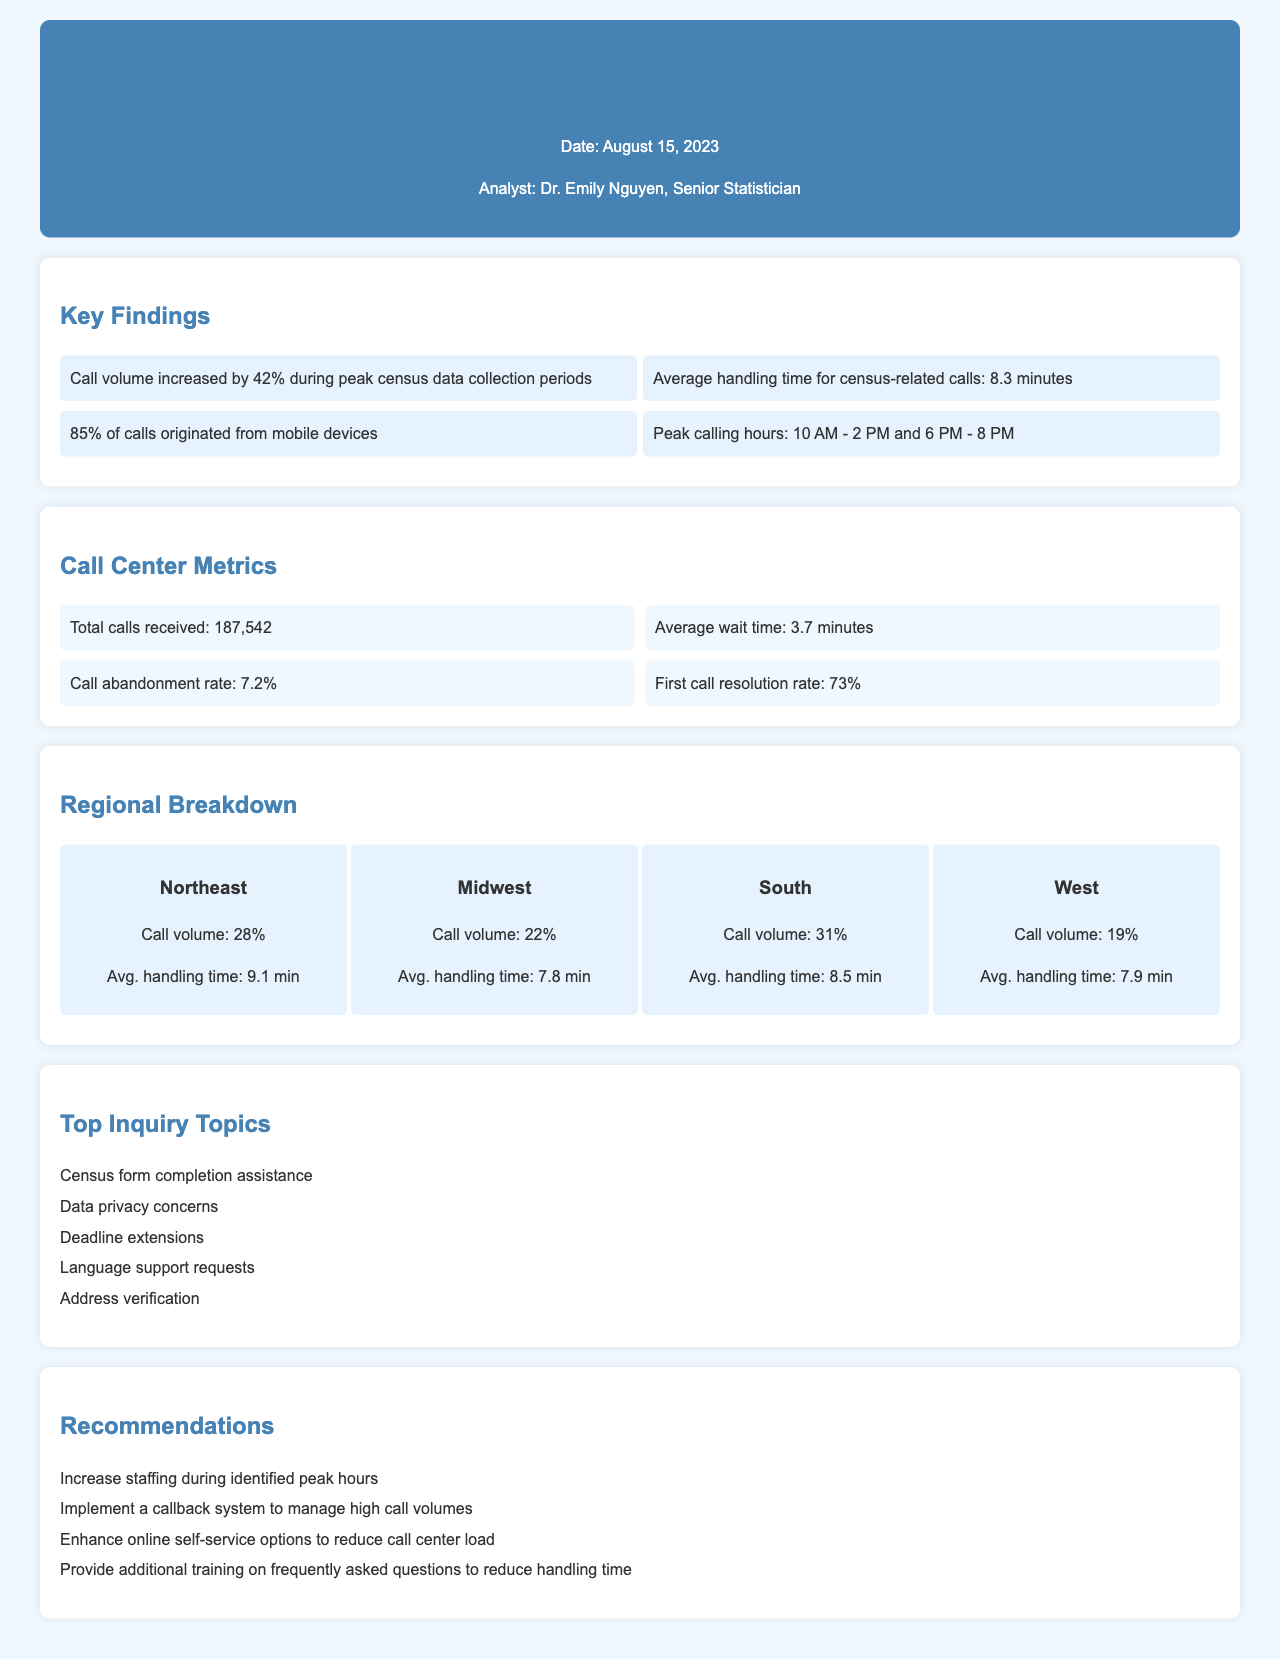What was the increase in call volume during peak census data collection periods? Call volume increased by 42% during peak census data collection periods as stated in the key findings.
Answer: 42% What is the average handling time for census-related calls? The average handling time for census-related calls is specified in the key findings of the document as 8.3 minutes.
Answer: 8.3 minutes What percentage of calls originated from mobile devices? The document states that 85% of calls originated from mobile devices, which is detailed in the key findings section.
Answer: 85% What are the peak calling hours according to the document? The peak calling hours are identified as 10 AM to 2 PM and 6 PM to 8 PM based on the key findings.
Answer: 10 AM - 2 PM and 6 PM - 8 PM What is the total number of calls received? The total calls received is explicitly mentioned in the call center metrics as 187,542 calls.
Answer: 187,542 Which region had the highest call volume percentage? The Northeast region had the highest call volume with 28%, as detailed in the regional breakdown section.
Answer: Northeast What is the average wait time for calls? The average wait time is stated in the call center metrics section as 3.7 minutes.
Answer: 3.7 minutes What percentage represents the call abandonment rate? The call abandonment rate is indicated in the call center metrics section as 7.2%.
Answer: 7.2% What is one of the recommendations for managing high call volumes? One recommendation from the document to manage high call volumes is to implement a callback system.
Answer: Implement a callback system 